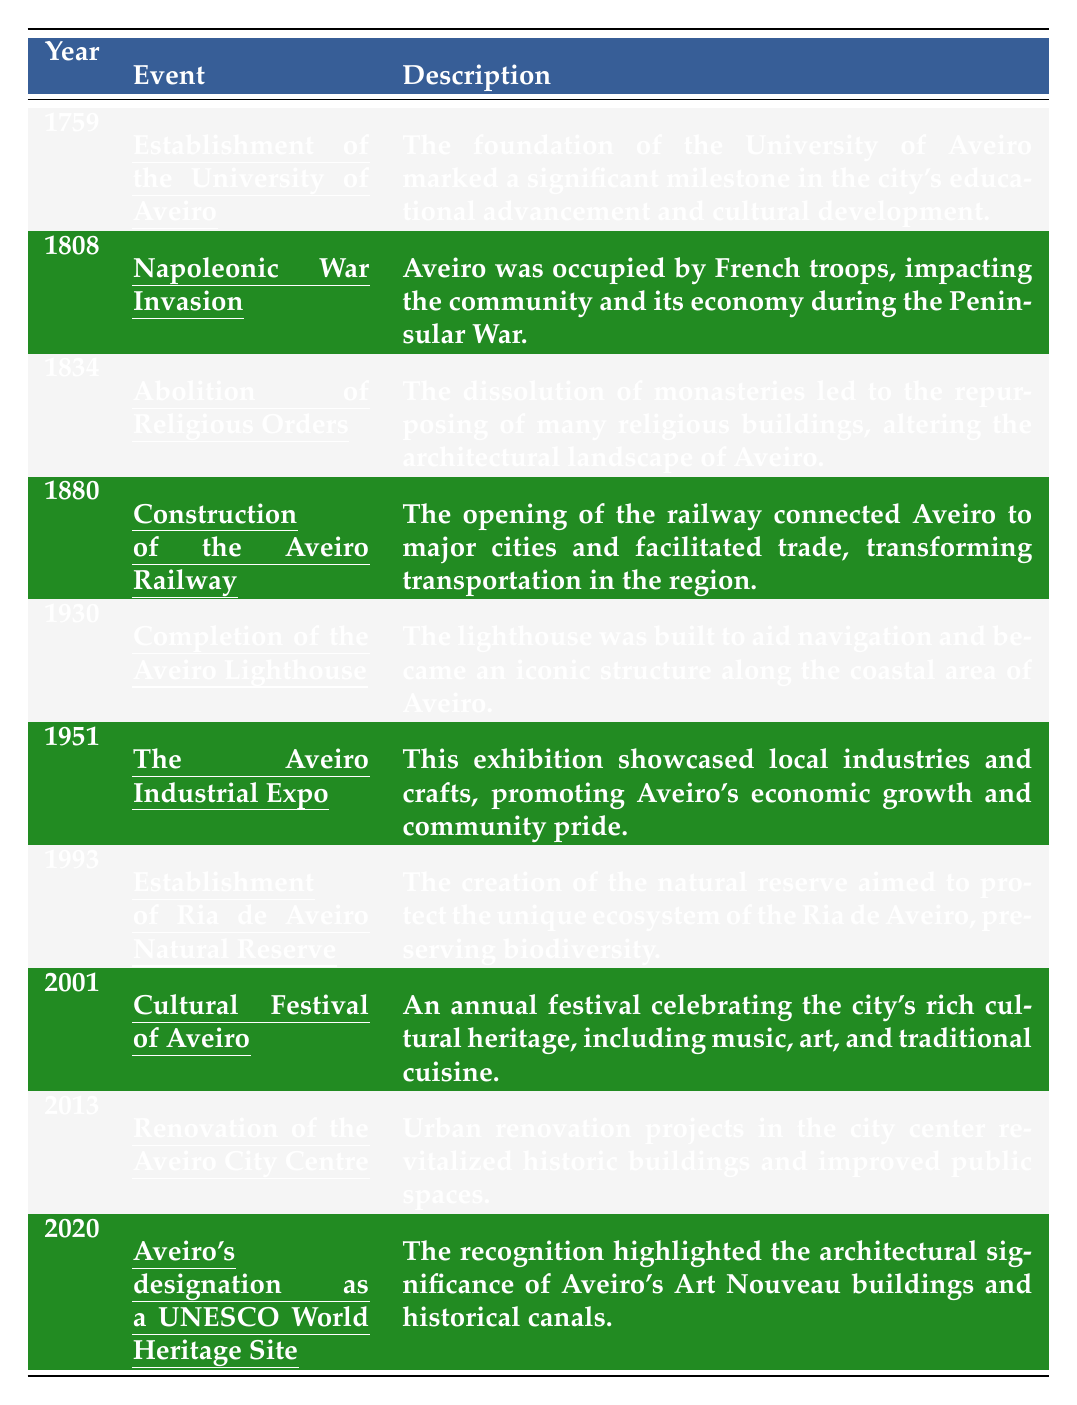What year was the University of Aveiro established? The table indicates that the University of Aveiro was established in the year 1759, as listed in the "Year" column corresponding to "Establishment of the University of Aveiro."
Answer: 1759 Which event occurred during the Napoleonic War in Aveiro? According to the table, the event listed for the year 1808 is the “Napoleonic War Invasion,” which describes the occupation of Aveiro by French troops.
Answer: Napoleonic War Invasion How many significant events are listed in the table? A count of the events in the table shows there are ten entries from 1759 to 2020, indicating significant milestones in Aveiro's history.
Answer: Ten Which event led to changes in the architectural landscape of Aveiro? The table mentions the “Abolition of Religious Orders” in 1834, which led to the repurposing of religious buildings, thus changing the architectural landscape.
Answer: Abolition of Religious Orders What is the median year of the events listed? The years listed in the table are: 1759, 1808, 1834, 1880, 1930, 1951, 1993, 2001, 2013, 2020. When arranged, the median can be found by taking the average of the 5th and 6th values (1930 and 1951), which results in (1930 + 1951) / 2 = 1940.5.
Answer: 1940.5 True or False: The Aveiro Lighthouse was completed before the establishment of Ria de Aveiro Natural Reserve. The table indicates the Lighthouse was completed in 1930 and the Natural Reserve was established in 1993, confirming that the Lighthouse was indeed completed first.
Answer: True Which two events occurred in different centuries, and what years did they take place? The "Construction of the Aveiro Railway" took place in 1880 (19th century) and "Aveiro's designation as a UNESCO World Heritage Site" occurred in 2020 (21st century), indicating they are from different centuries.
Answer: 1880 and 2020 What was the impact of the Aveiro Industrial Expo in 1951? The description states that the Aveiro Industrial Expo showcased local industries and crafts, promoting economic growth and community pride, highlighting its significant impact on the city.
Answer: Economic growth and community pride Did the establishment of the University of Aveiro have an impact on cultural development? Yes, the table states that the foundation of the University marked a milestone in educational advancement and cultural development, confirming its impact.
Answer: Yes What was the main purpose of the Ria de Aveiro Natural Reserve established in 1993? The table specifies that the purpose of the Natural Reserve is to protect the unique ecosystem of the Ria de Aveiro, emphasizing its role in biodiversity preservation.
Answer: Preserve biodiversity 